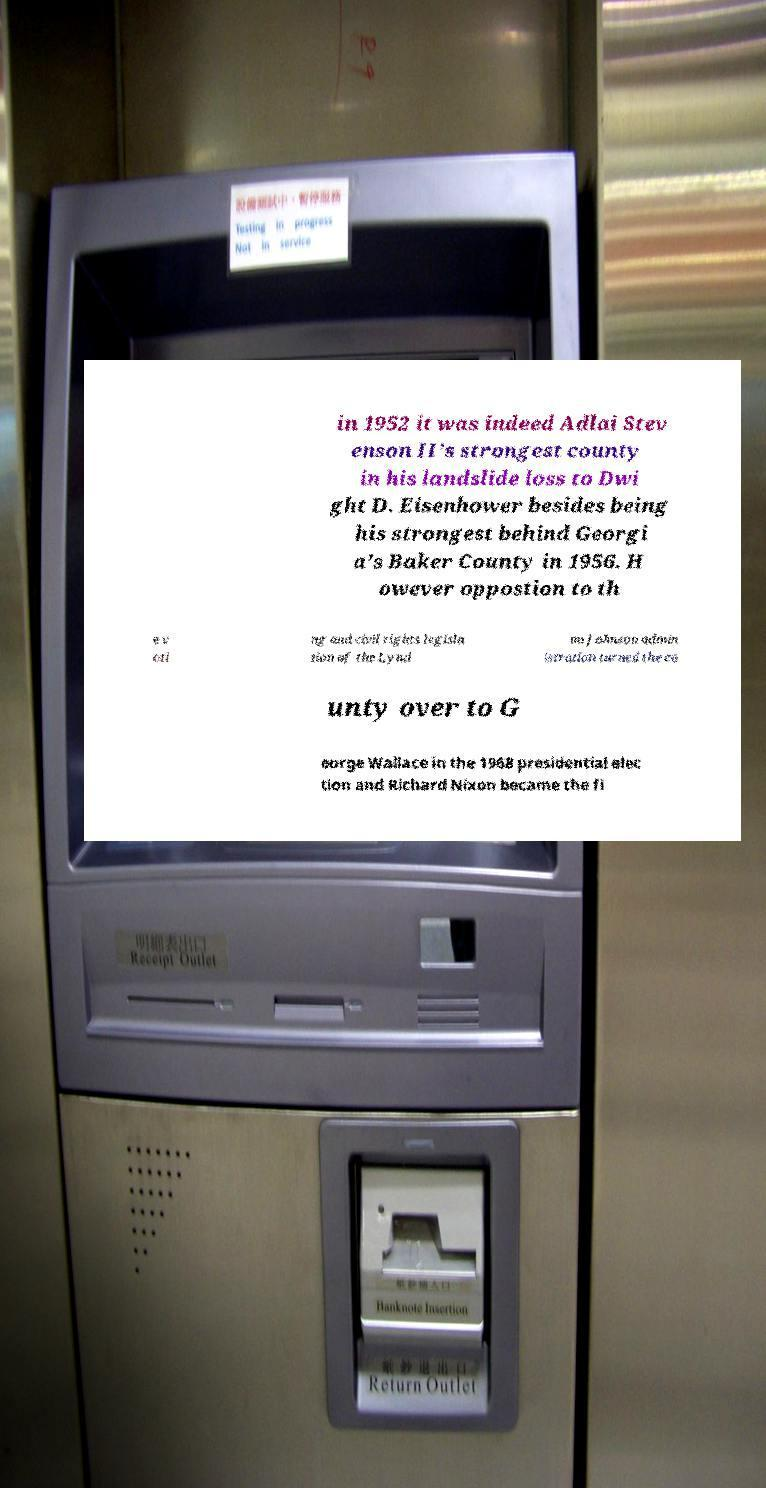There's text embedded in this image that I need extracted. Can you transcribe it verbatim? in 1952 it was indeed Adlai Stev enson II’s strongest county in his landslide loss to Dwi ght D. Eisenhower besides being his strongest behind Georgi a’s Baker County in 1956. H owever oppostion to th e v oti ng and civil rights legisla tion of the Lynd on Johnson admin istration turned the co unty over to G eorge Wallace in the 1968 presidential elec tion and Richard Nixon became the fi 